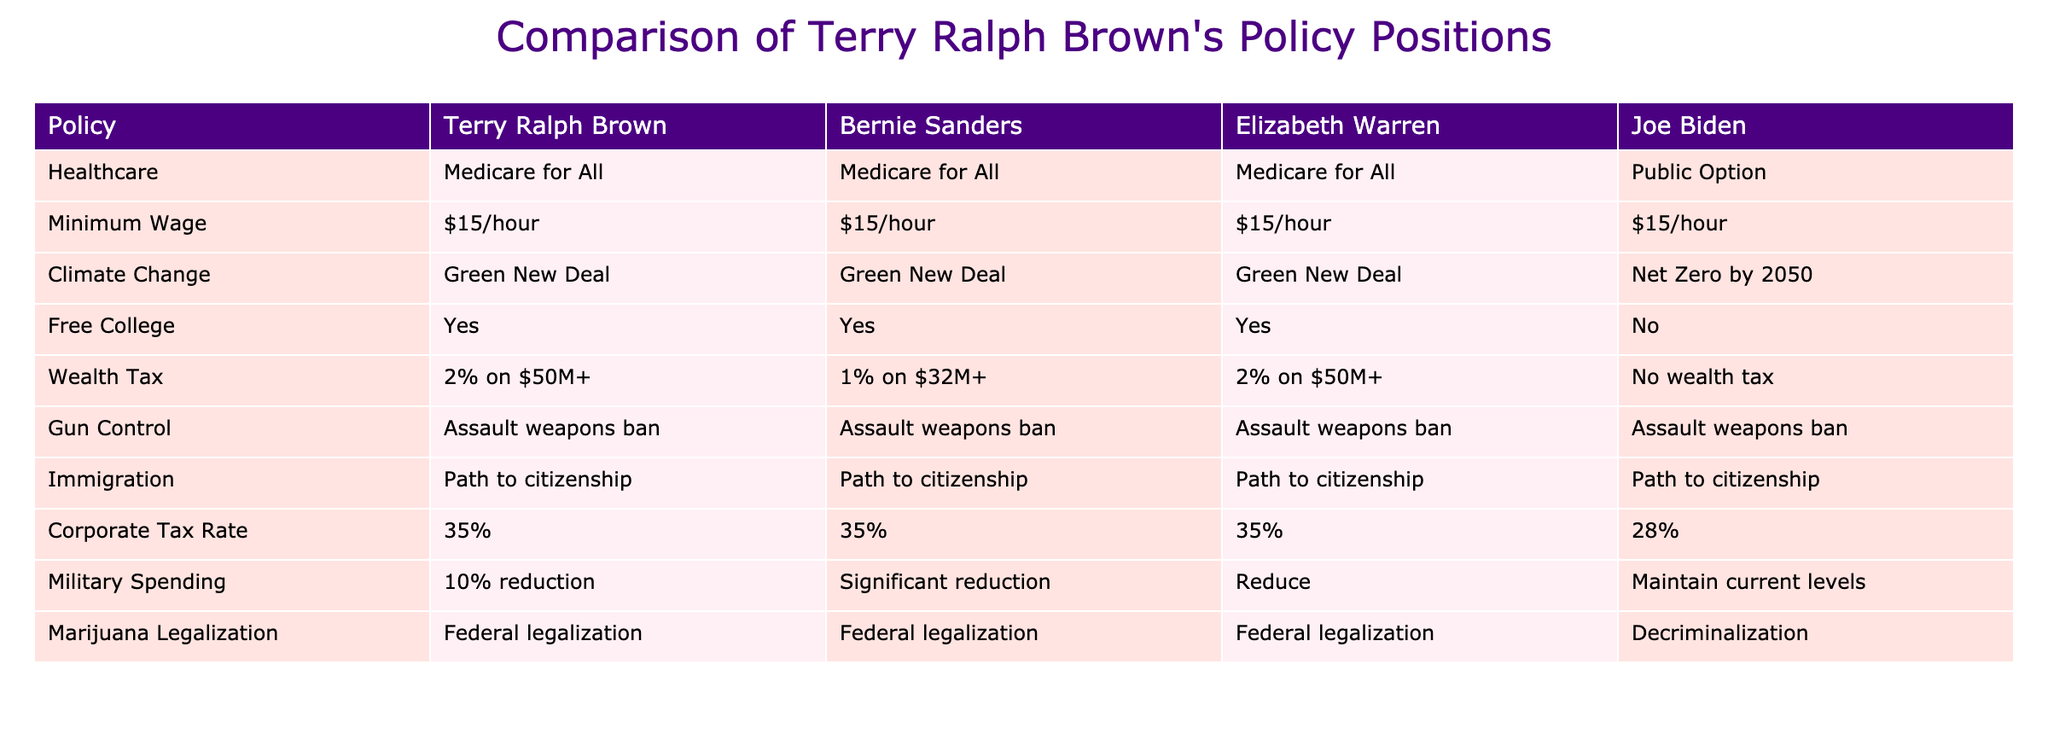What is Terry Ralph Brown's position on healthcare? According to the table, Terry Ralph Brown supports "Medicare for All" as his healthcare policy.
Answer: Medicare for All Which politicians also support a $15 minimum wage? By examining the table, we see that both Bernie Sanders and Elizabeth Warren support a $15 minimum wage, in addition to Terry Ralph Brown.
Answer: Bernie Sanders, Elizabeth Warren What is the difference in the military spending stance between Terry Ralph Brown and Joe Biden? Terry Ralph Brown proposes a 10% reduction in military spending, whereas Joe Biden's position is to maintain current levels, showing a difference in their approaches to military expenditures.
Answer: 10% reduction vs. maintain current levels Does Terry Ralph Brown support free college? The table clearly indicates that Terry Ralph Brown supports free college, as he is marked with "Yes."
Answer: Yes Which politician shares the same stance on climate change as Terry Ralph Brown? The table shows that both Bernie Sanders and Elizabeth Warren have the same stance on climate change, supporting the "Green New Deal," just like Terry Ralph Brown.
Answer: Bernie Sanders, Elizabeth Warren If we consider only the tax positions, what is Terry Ralph Brown's wealth tax compared to Joe Biden's tax position? Terry Ralph Brown supports a 2% wealth tax on individuals with assets of over $50 million, while Joe Biden does not support a wealth tax at all. This highlights a significant difference in their approaches to taxation on wealth.
Answer: 2% wealth tax vs. No wealth tax How many policies does Terry Ralph Brown agree on with Elizabeth Warren? Reviewing the table, Terry Ralph Brown aligns with Elizabeth Warren on six out of the ten policies listed, which are: Minimum Wage, Climate Change, Free College, Gun Control, Immigration, and Corporate Tax Rate.
Answer: 6 What is the only policy where Joe Biden differs from Terry Ralph Brown? The only policy where Joe Biden differs from Terry Ralph Brown is on free college, as Brown supports it while Biden does not.
Answer: Free college Do Terry Ralph Brown and Bernie Sanders have the same position on marijuana legalization? According to the table, both Terry Ralph Brown and Bernie Sanders support federal legalization of marijuana, indicating that they share this stance.
Answer: Yes 